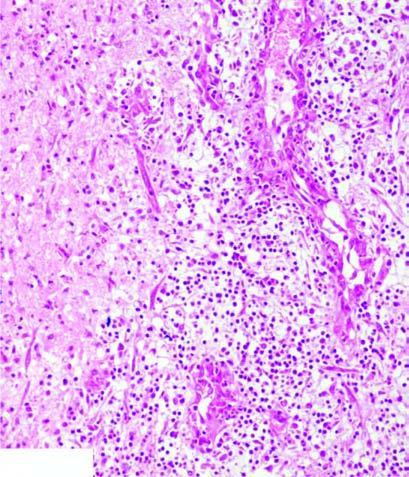does the interface between viable and non-viable area show granulation tissue and gliosis?
Answer the question using a single word or phrase. No 